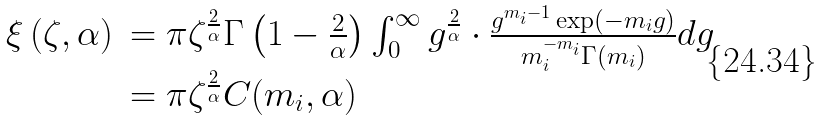<formula> <loc_0><loc_0><loc_500><loc_500>\begin{array} { l l } \xi \left ( \zeta , \alpha \right ) & = \pi \zeta ^ { \frac { 2 } { \alpha } } \Gamma \left ( 1 - \frac { 2 } { \alpha } \right ) \int _ { 0 } ^ { \infty } g ^ { \frac { 2 } { \alpha } } \cdot \frac { g ^ { m _ { i } - 1 } \exp ( - m _ { i } g ) } { m _ { i } ^ { - m _ { i } } \Gamma ( m _ { i } ) } d g \\ & = \pi \zeta ^ { \frac { 2 } { \alpha } } C ( m _ { i } , \alpha ) \end{array}</formula> 